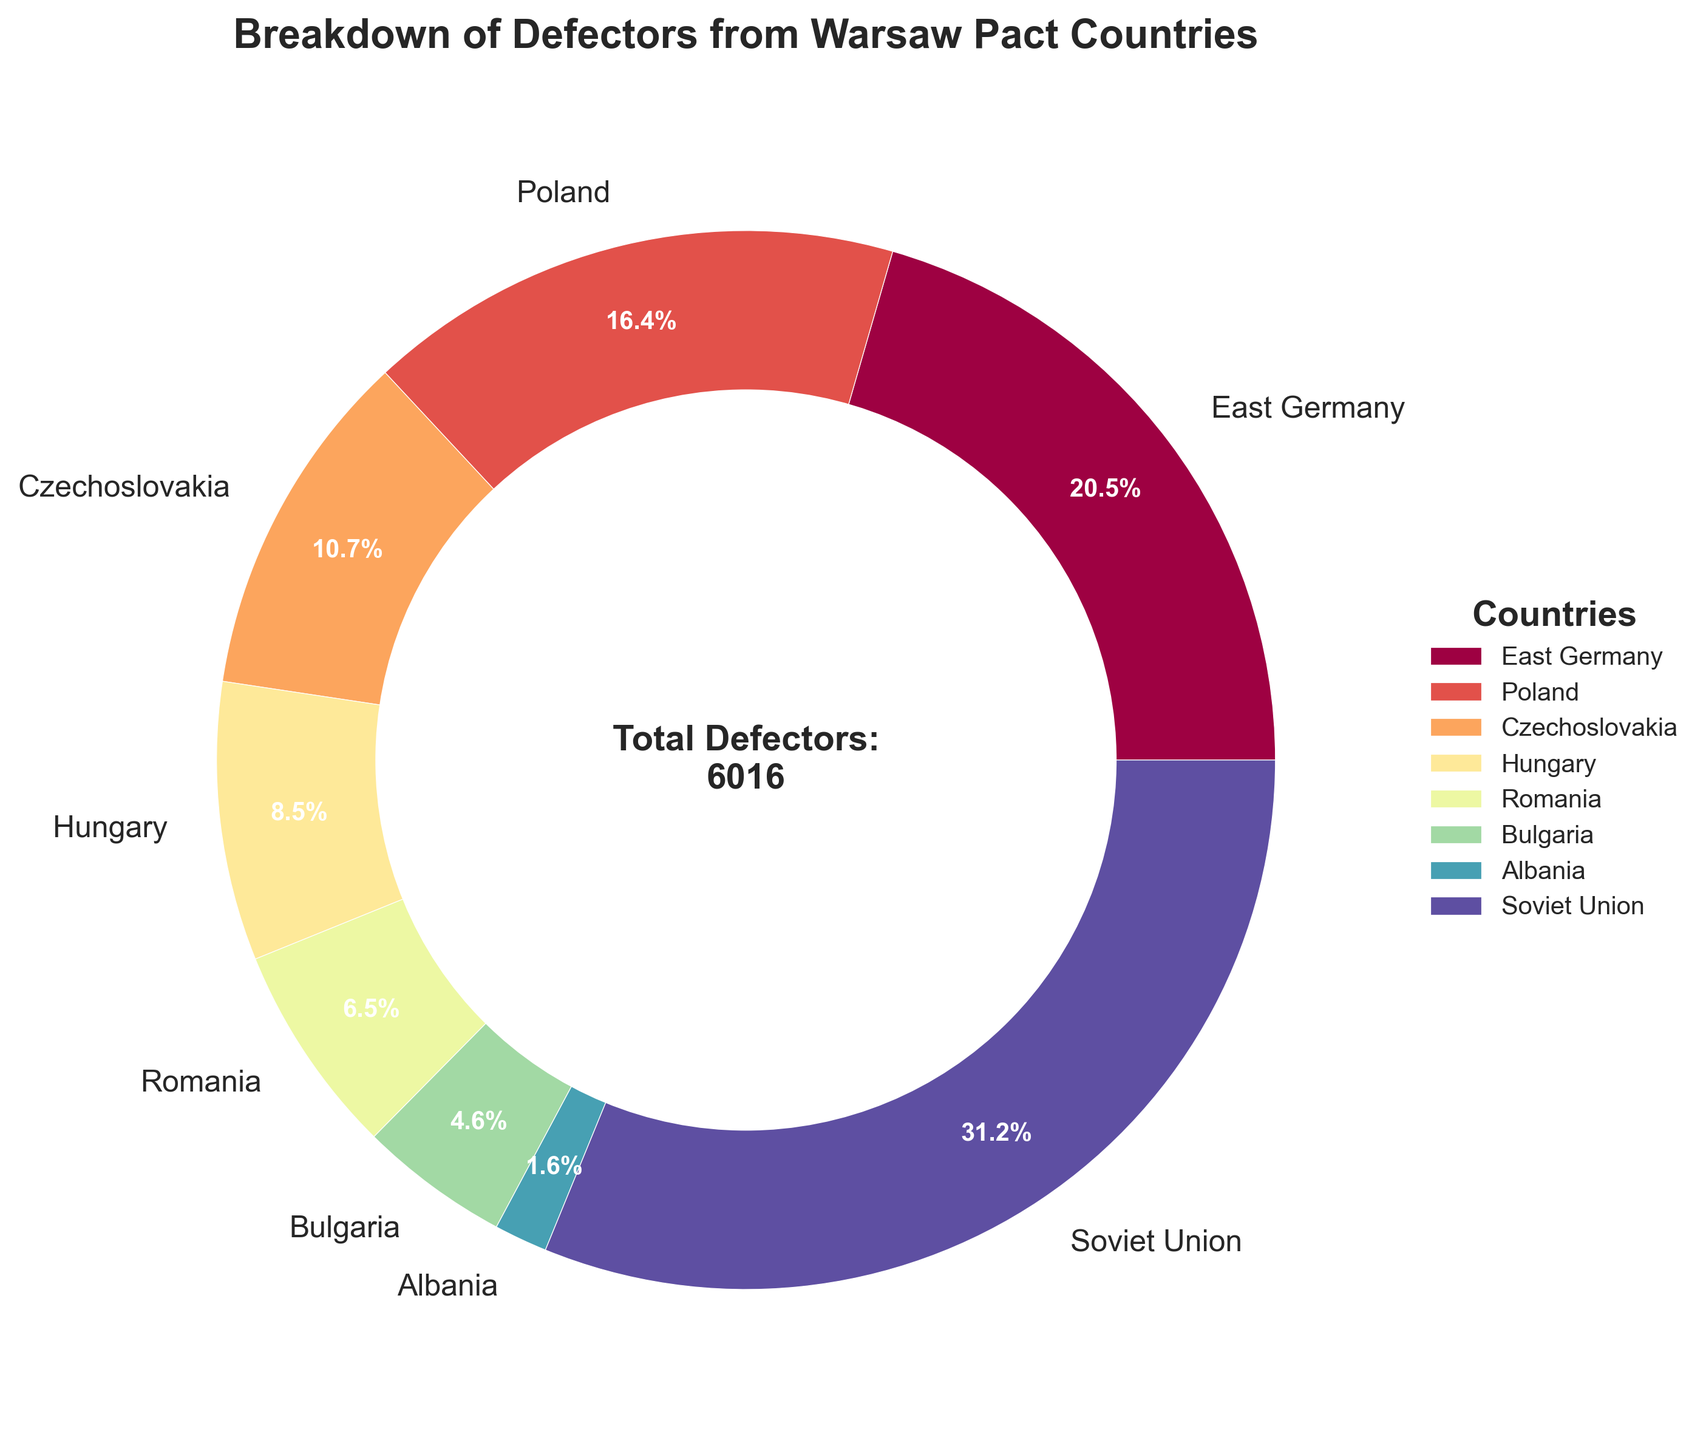Which country has the highest number of defectors? The largest portion of the pie chart represents defectors from the Soviet Union, which has the largest number compared to other countries.
Answer: Soviet Union What percentage of defectors does East Germany contribute? The pie chart indicates that East Germany's segment has a label showing a percentage. By locating the label for East Germany, we see it is 18.2%.
Answer: 18.2% How many defectors in total came from Czechoslovakia and Romania combined? Refer to the pie chart for the defectors from Czechoslovakia (643) and Romania (389). Add these numbers: 643 + 389.
Answer: 1032 Which country has fewer defectors, Bulgaria or Albania? The pie chart segments for Bulgaria and Albania can be compared directly. The label for Albania shows 98 defectors, while Bulgaria's label shows 276, indicating Bulgaria has more defectors.
Answer: Albania What is the difference in the number of defectors between Poland and Hungary? Referring to the pie chart, Poland has 987 defectors, and Hungary has 512. Subtract Hungary's defectors from Poland's: 987 - 512.
Answer: 475 What is the approximate percentage of defectors from Warsaw Pact countries that came from the Soviet Union? The pie chart segment for the Soviet Union shows a percentage. Locate the Soviet Union's label to see the percentage.
Answer: 27.7% Which two countries together account for approximately 45% of defectors? Referring to the pie chart, add the percentages of various pairs to identify the pair that sums to 45%. The Soviet Union (27.7%) and East Germany (18.2%) together sum to approximately 45.9%.
Answer: Soviet Union and East Germany How many more defectors did East Germany have compared to Bulgaria? From the pie chart, note that East Germany has 1235 defectors and Bulgaria has 276. Subtract Bulgaria's defectors from East Germany's: 1235 - 276.
Answer: 959 What is the total number of defectors represented in the pie chart? The pie chart includes the total number of defectors in the center: 6016.
Answer: 6016 Which country, out of Hungary and Romania, contributes a higher number of defectors, and by how much? The pie chart shows Hungary with 512 defectors and Romania with 389. Subtract Romania's defectors from Hungary's: 512 - 389.
Answer: Hungary by 123 